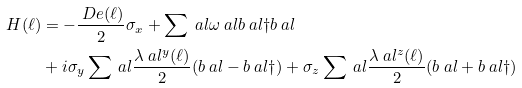Convert formula to latex. <formula><loc_0><loc_0><loc_500><loc_500>H ( \ell ) & = - \frac { \ D e ( \ell ) } { 2 } \sigma _ { x } + \sum \ a l \omega \ a l b \ a l \dag b \ a l \\ & + i \sigma _ { y } \sum \ a l \frac { \lambda \ a l ^ { y } ( \ell ) } { 2 } ( b \ a l - b \ a l \dag ) + \sigma _ { z } \sum \ a l \frac { \lambda \ a l ^ { z } ( \ell ) } { 2 } ( b \ a l + b \ a l \dag )</formula> 